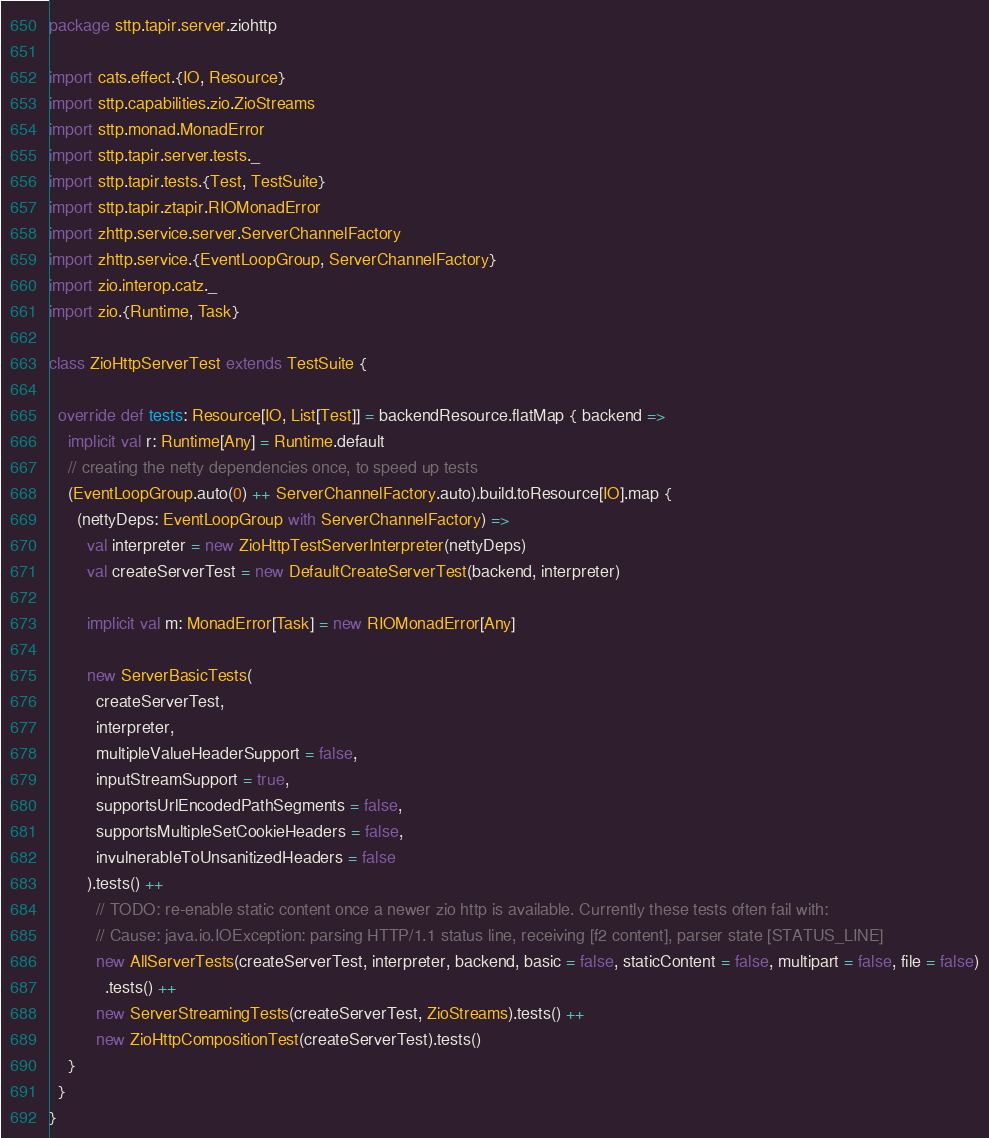Convert code to text. <code><loc_0><loc_0><loc_500><loc_500><_Scala_>package sttp.tapir.server.ziohttp

import cats.effect.{IO, Resource}
import sttp.capabilities.zio.ZioStreams
import sttp.monad.MonadError
import sttp.tapir.server.tests._
import sttp.tapir.tests.{Test, TestSuite}
import sttp.tapir.ztapir.RIOMonadError
import zhttp.service.server.ServerChannelFactory
import zhttp.service.{EventLoopGroup, ServerChannelFactory}
import zio.interop.catz._
import zio.{Runtime, Task}

class ZioHttpServerTest extends TestSuite {

  override def tests: Resource[IO, List[Test]] = backendResource.flatMap { backend =>
    implicit val r: Runtime[Any] = Runtime.default
    // creating the netty dependencies once, to speed up tests
    (EventLoopGroup.auto(0) ++ ServerChannelFactory.auto).build.toResource[IO].map {
      (nettyDeps: EventLoopGroup with ServerChannelFactory) =>
        val interpreter = new ZioHttpTestServerInterpreter(nettyDeps)
        val createServerTest = new DefaultCreateServerTest(backend, interpreter)

        implicit val m: MonadError[Task] = new RIOMonadError[Any]

        new ServerBasicTests(
          createServerTest,
          interpreter,
          multipleValueHeaderSupport = false,
          inputStreamSupport = true,
          supportsUrlEncodedPathSegments = false,
          supportsMultipleSetCookieHeaders = false,
          invulnerableToUnsanitizedHeaders = false
        ).tests() ++
          // TODO: re-enable static content once a newer zio http is available. Currently these tests often fail with:
          // Cause: java.io.IOException: parsing HTTP/1.1 status line, receiving [f2 content], parser state [STATUS_LINE]
          new AllServerTests(createServerTest, interpreter, backend, basic = false, staticContent = false, multipart = false, file = false)
            .tests() ++
          new ServerStreamingTests(createServerTest, ZioStreams).tests() ++
          new ZioHttpCompositionTest(createServerTest).tests()
    }
  }
}
</code> 